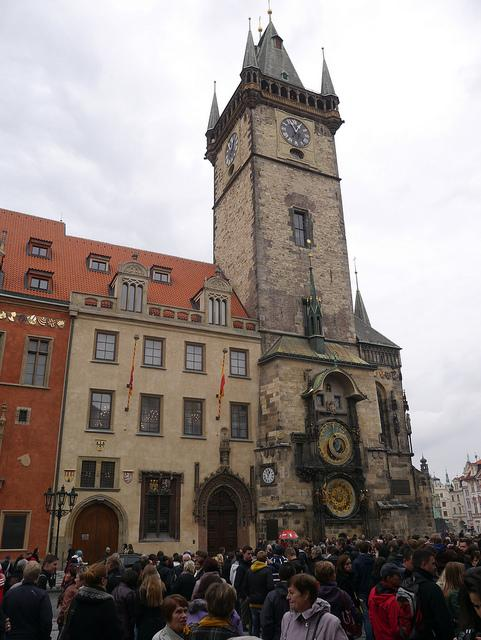What is the black circular object near the top of the tower used for? telling time 